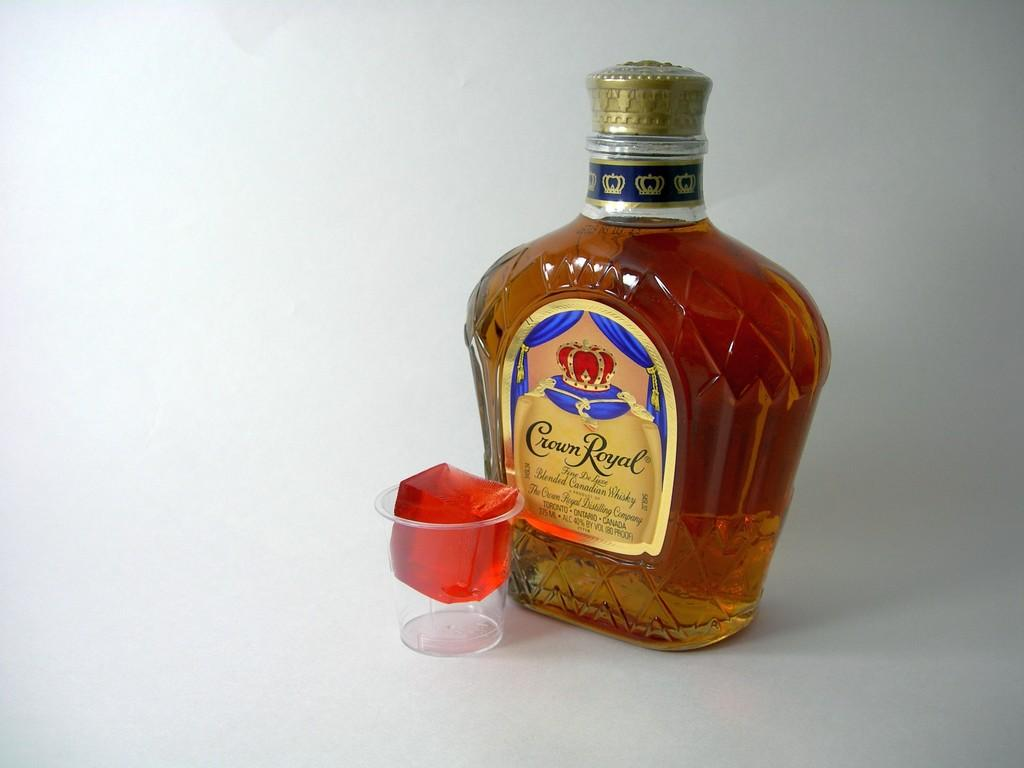What can be seen in the image that contains a liquid? There is a bottle in the image that contains liquid. What else is present in the image that can hold a liquid? There is a glass in the image. What is inside the glass? The glass contains an object. What type of jeans can be seen hanging on the bottle in the image? There are no jeans present in the image; the bottle contains liquid, and the glass contains an object. 